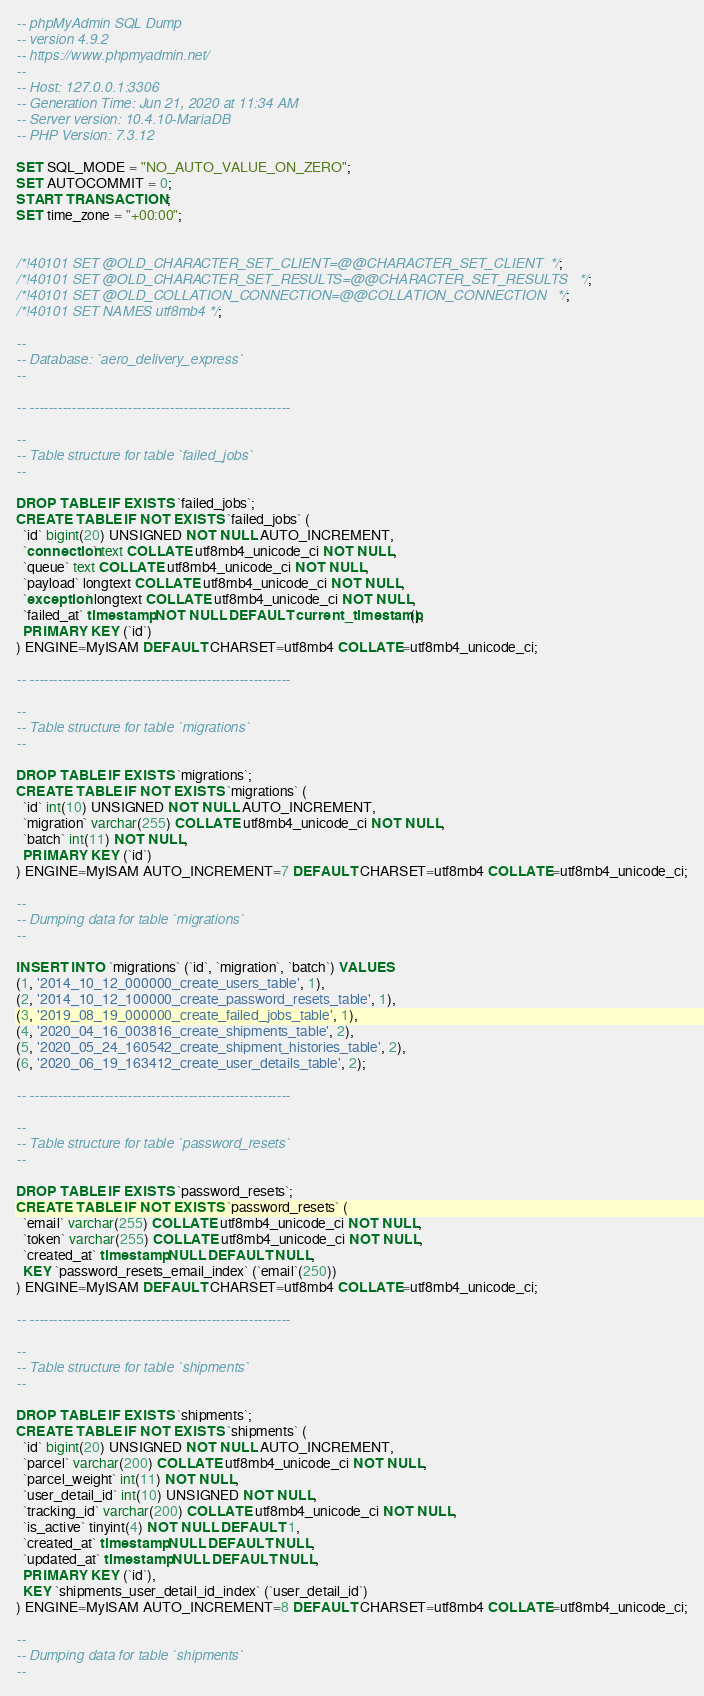Convert code to text. <code><loc_0><loc_0><loc_500><loc_500><_SQL_>-- phpMyAdmin SQL Dump
-- version 4.9.2
-- https://www.phpmyadmin.net/
--
-- Host: 127.0.0.1:3306
-- Generation Time: Jun 21, 2020 at 11:34 AM
-- Server version: 10.4.10-MariaDB
-- PHP Version: 7.3.12

SET SQL_MODE = "NO_AUTO_VALUE_ON_ZERO";
SET AUTOCOMMIT = 0;
START TRANSACTION;
SET time_zone = "+00:00";


/*!40101 SET @OLD_CHARACTER_SET_CLIENT=@@CHARACTER_SET_CLIENT */;
/*!40101 SET @OLD_CHARACTER_SET_RESULTS=@@CHARACTER_SET_RESULTS */;
/*!40101 SET @OLD_COLLATION_CONNECTION=@@COLLATION_CONNECTION */;
/*!40101 SET NAMES utf8mb4 */;

--
-- Database: `aero_delivery_express`
--

-- --------------------------------------------------------

--
-- Table structure for table `failed_jobs`
--

DROP TABLE IF EXISTS `failed_jobs`;
CREATE TABLE IF NOT EXISTS `failed_jobs` (
  `id` bigint(20) UNSIGNED NOT NULL AUTO_INCREMENT,
  `connection` text COLLATE utf8mb4_unicode_ci NOT NULL,
  `queue` text COLLATE utf8mb4_unicode_ci NOT NULL,
  `payload` longtext COLLATE utf8mb4_unicode_ci NOT NULL,
  `exception` longtext COLLATE utf8mb4_unicode_ci NOT NULL,
  `failed_at` timestamp NOT NULL DEFAULT current_timestamp(),
  PRIMARY KEY (`id`)
) ENGINE=MyISAM DEFAULT CHARSET=utf8mb4 COLLATE=utf8mb4_unicode_ci;

-- --------------------------------------------------------

--
-- Table structure for table `migrations`
--

DROP TABLE IF EXISTS `migrations`;
CREATE TABLE IF NOT EXISTS `migrations` (
  `id` int(10) UNSIGNED NOT NULL AUTO_INCREMENT,
  `migration` varchar(255) COLLATE utf8mb4_unicode_ci NOT NULL,
  `batch` int(11) NOT NULL,
  PRIMARY KEY (`id`)
) ENGINE=MyISAM AUTO_INCREMENT=7 DEFAULT CHARSET=utf8mb4 COLLATE=utf8mb4_unicode_ci;

--
-- Dumping data for table `migrations`
--

INSERT INTO `migrations` (`id`, `migration`, `batch`) VALUES
(1, '2014_10_12_000000_create_users_table', 1),
(2, '2014_10_12_100000_create_password_resets_table', 1),
(3, '2019_08_19_000000_create_failed_jobs_table', 1),
(4, '2020_04_16_003816_create_shipments_table', 2),
(5, '2020_05_24_160542_create_shipment_histories_table', 2),
(6, '2020_06_19_163412_create_user_details_table', 2);

-- --------------------------------------------------------

--
-- Table structure for table `password_resets`
--

DROP TABLE IF EXISTS `password_resets`;
CREATE TABLE IF NOT EXISTS `password_resets` (
  `email` varchar(255) COLLATE utf8mb4_unicode_ci NOT NULL,
  `token` varchar(255) COLLATE utf8mb4_unicode_ci NOT NULL,
  `created_at` timestamp NULL DEFAULT NULL,
  KEY `password_resets_email_index` (`email`(250))
) ENGINE=MyISAM DEFAULT CHARSET=utf8mb4 COLLATE=utf8mb4_unicode_ci;

-- --------------------------------------------------------

--
-- Table structure for table `shipments`
--

DROP TABLE IF EXISTS `shipments`;
CREATE TABLE IF NOT EXISTS `shipments` (
  `id` bigint(20) UNSIGNED NOT NULL AUTO_INCREMENT,
  `parcel` varchar(200) COLLATE utf8mb4_unicode_ci NOT NULL,
  `parcel_weight` int(11) NOT NULL,
  `user_detail_id` int(10) UNSIGNED NOT NULL,
  `tracking_id` varchar(200) COLLATE utf8mb4_unicode_ci NOT NULL,
  `is_active` tinyint(4) NOT NULL DEFAULT 1,
  `created_at` timestamp NULL DEFAULT NULL,
  `updated_at` timestamp NULL DEFAULT NULL,
  PRIMARY KEY (`id`),
  KEY `shipments_user_detail_id_index` (`user_detail_id`)
) ENGINE=MyISAM AUTO_INCREMENT=8 DEFAULT CHARSET=utf8mb4 COLLATE=utf8mb4_unicode_ci;

--
-- Dumping data for table `shipments`
--
</code> 